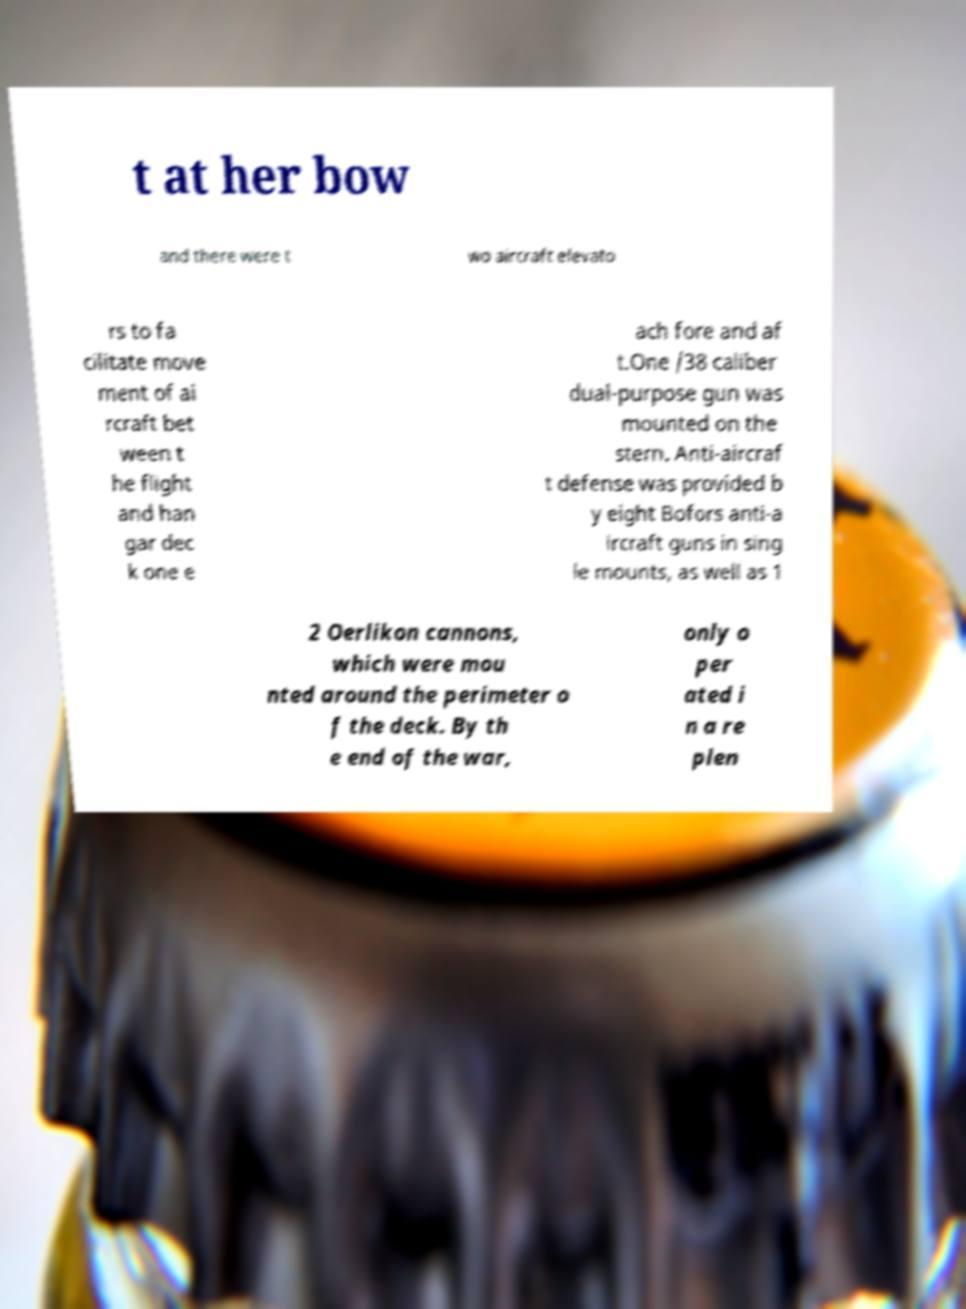There's text embedded in this image that I need extracted. Can you transcribe it verbatim? t at her bow and there were t wo aircraft elevato rs to fa cilitate move ment of ai rcraft bet ween t he flight and han gar dec k one e ach fore and af t.One /38 caliber dual-purpose gun was mounted on the stern. Anti-aircraf t defense was provided b y eight Bofors anti-a ircraft guns in sing le mounts, as well as 1 2 Oerlikon cannons, which were mou nted around the perimeter o f the deck. By th e end of the war, only o per ated i n a re plen 